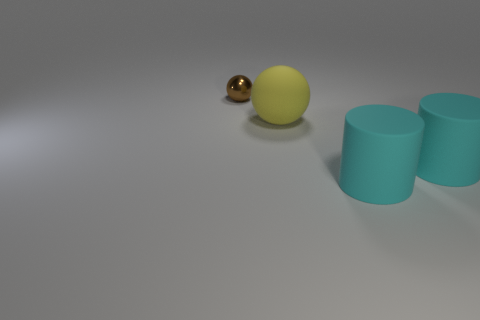Is there any other thing that is the same size as the brown metal object?
Keep it short and to the point. No. Is there any other thing that is the same material as the tiny thing?
Give a very brief answer. No. There is a brown shiny object; is it the same size as the sphere that is to the right of the tiny sphere?
Your answer should be very brief. No. Is the size of the ball that is behind the large yellow rubber ball the same as the ball that is on the right side of the brown thing?
Offer a terse response. No. Are there any other spheres that have the same material as the large sphere?
Make the answer very short. No. Is the ball that is in front of the brown sphere made of the same material as the ball that is behind the yellow ball?
Give a very brief answer. No. Is the number of tiny yellow cylinders greater than the number of big yellow things?
Keep it short and to the point. No. What is the color of the sphere that is to the right of the ball that is behind the sphere that is on the right side of the brown sphere?
Offer a very short reply. Yellow. There is a ball that is left of the yellow thing; is its color the same as the sphere that is to the right of the brown metallic object?
Give a very brief answer. No. There is a ball behind the yellow ball; what number of yellow things are right of it?
Give a very brief answer. 1. 